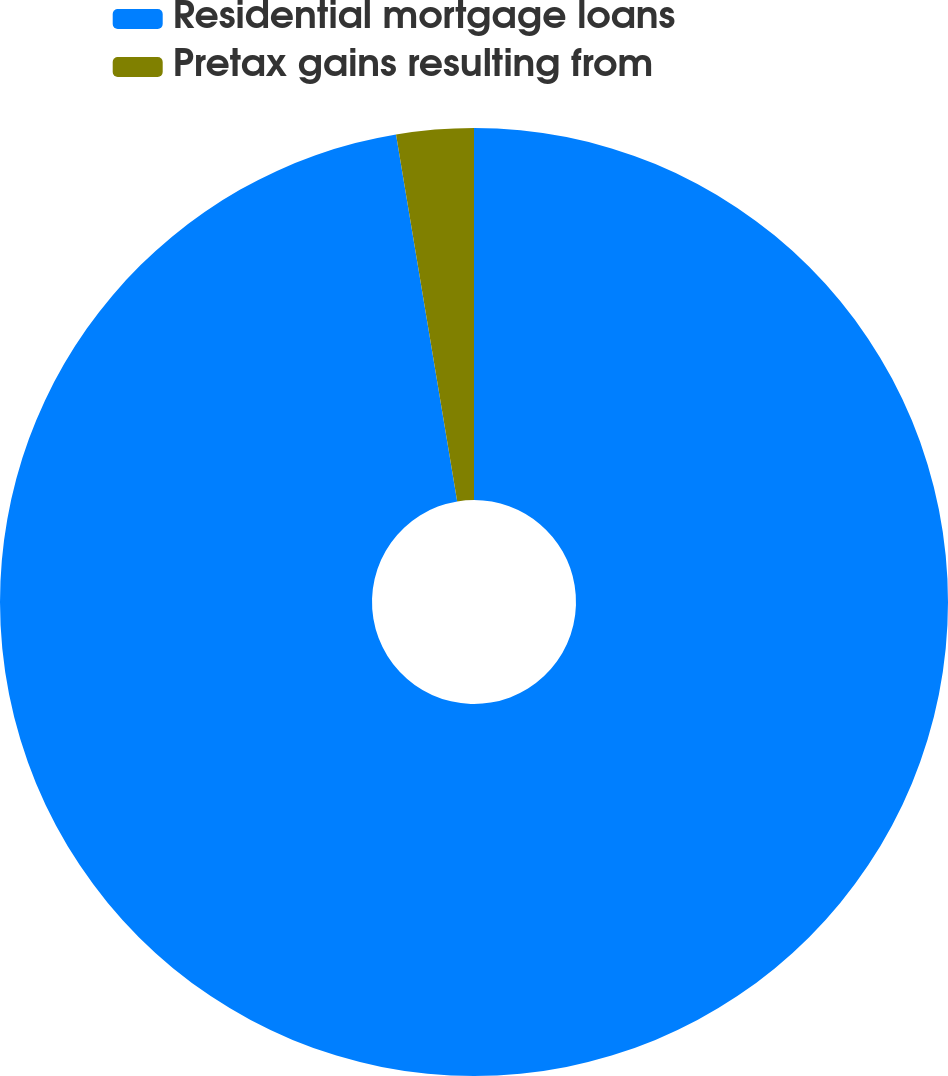Convert chart to OTSL. <chart><loc_0><loc_0><loc_500><loc_500><pie_chart><fcel>Residential mortgage loans<fcel>Pretax gains resulting from<nl><fcel>97.37%<fcel>2.63%<nl></chart> 